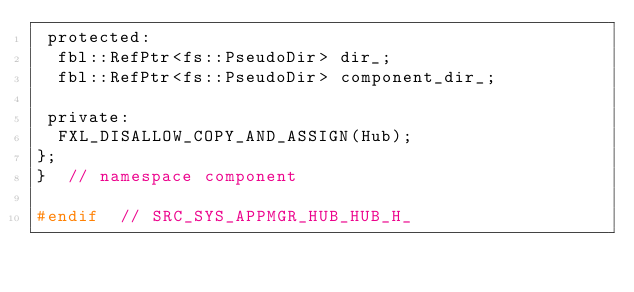Convert code to text. <code><loc_0><loc_0><loc_500><loc_500><_C_> protected:
  fbl::RefPtr<fs::PseudoDir> dir_;
  fbl::RefPtr<fs::PseudoDir> component_dir_;

 private:
  FXL_DISALLOW_COPY_AND_ASSIGN(Hub);
};
}  // namespace component

#endif  // SRC_SYS_APPMGR_HUB_HUB_H_
</code> 